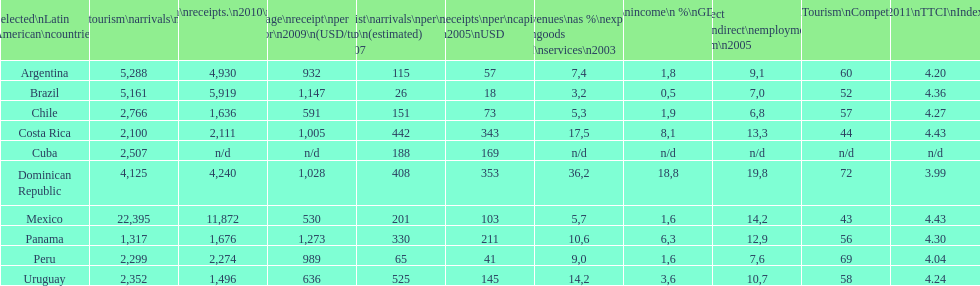What country had the least arrivals per 1000 inhabitants in 2007(estimated)? Brazil. Would you be able to parse every entry in this table? {'header': ['Selected\\nLatin American\\ncountries', 'Internl.\\ntourism\\narrivals\\n2010\\n(x 1000)', 'Internl.\\ntourism\\nreceipts.\\n2010\\n(USD\\n(x1000)', 'Average\\nreceipt\\nper visitor\\n2009\\n(USD/turista)', 'Tourist\\narrivals\\nper\\n1000 inhab\\n(estimated) \\n2007', 'Receipts\\nper\\ncapita \\n2005\\nUSD', 'Revenues\\nas\xa0%\\nexports of\\ngoods and\\nservices\\n2003', 'Tourism\\nincome\\n\xa0%\\nGDP\\n2003', '% Direct and\\nindirect\\nemployment\\nin tourism\\n2005', 'World\\nranking\\nTourism\\nCompetitiv.\\nTTCI\\n2011', '2011\\nTTCI\\nIndex'], 'rows': [['Argentina', '5,288', '4,930', '932', '115', '57', '7,4', '1,8', '9,1', '60', '4.20'], ['Brazil', '5,161', '5,919', '1,147', '26', '18', '3,2', '0,5', '7,0', '52', '4.36'], ['Chile', '2,766', '1,636', '591', '151', '73', '5,3', '1,9', '6,8', '57', '4.27'], ['Costa Rica', '2,100', '2,111', '1,005', '442', '343', '17,5', '8,1', '13,3', '44', '4.43'], ['Cuba', '2,507', 'n/d', 'n/d', '188', '169', 'n/d', 'n/d', 'n/d', 'n/d', 'n/d'], ['Dominican Republic', '4,125', '4,240', '1,028', '408', '353', '36,2', '18,8', '19,8', '72', '3.99'], ['Mexico', '22,395', '11,872', '530', '201', '103', '5,7', '1,6', '14,2', '43', '4.43'], ['Panama', '1,317', '1,676', '1,273', '330', '211', '10,6', '6,3', '12,9', '56', '4.30'], ['Peru', '2,299', '2,274', '989', '65', '41', '9,0', '1,6', '7,6', '69', '4.04'], ['Uruguay', '2,352', '1,496', '636', '525', '145', '14,2', '3,6', '10,7', '58', '4.24']]} 